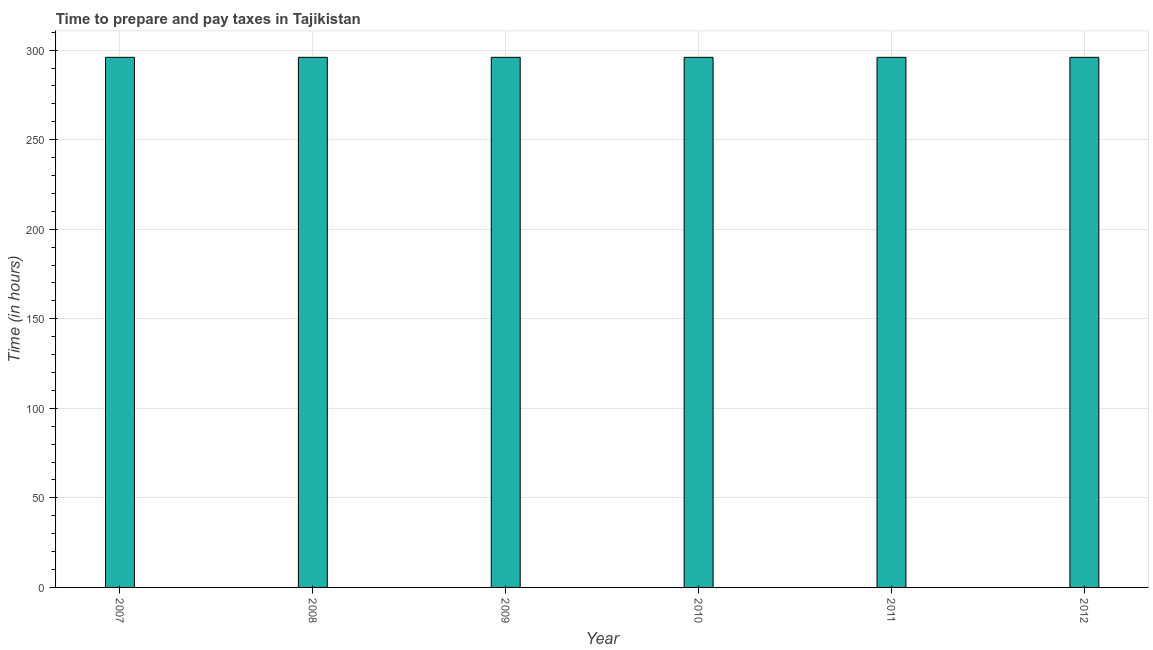Does the graph contain grids?
Your answer should be very brief. Yes. What is the title of the graph?
Ensure brevity in your answer.  Time to prepare and pay taxes in Tajikistan. What is the label or title of the Y-axis?
Provide a succinct answer. Time (in hours). What is the time to prepare and pay taxes in 2011?
Offer a very short reply. 296. Across all years, what is the maximum time to prepare and pay taxes?
Your response must be concise. 296. Across all years, what is the minimum time to prepare and pay taxes?
Your answer should be very brief. 296. In which year was the time to prepare and pay taxes maximum?
Your answer should be compact. 2007. What is the sum of the time to prepare and pay taxes?
Make the answer very short. 1776. What is the average time to prepare and pay taxes per year?
Provide a short and direct response. 296. What is the median time to prepare and pay taxes?
Ensure brevity in your answer.  296. What is the ratio of the time to prepare and pay taxes in 2007 to that in 2012?
Keep it short and to the point. 1. Is the time to prepare and pay taxes in 2010 less than that in 2012?
Provide a succinct answer. No. Is the difference between the time to prepare and pay taxes in 2010 and 2011 greater than the difference between any two years?
Offer a terse response. Yes. Is the sum of the time to prepare and pay taxes in 2011 and 2012 greater than the maximum time to prepare and pay taxes across all years?
Your response must be concise. Yes. What is the difference between the highest and the lowest time to prepare and pay taxes?
Keep it short and to the point. 0. In how many years, is the time to prepare and pay taxes greater than the average time to prepare and pay taxes taken over all years?
Ensure brevity in your answer.  0. Are the values on the major ticks of Y-axis written in scientific E-notation?
Provide a short and direct response. No. What is the Time (in hours) of 2007?
Ensure brevity in your answer.  296. What is the Time (in hours) of 2008?
Keep it short and to the point. 296. What is the Time (in hours) of 2009?
Provide a short and direct response. 296. What is the Time (in hours) in 2010?
Make the answer very short. 296. What is the Time (in hours) of 2011?
Make the answer very short. 296. What is the Time (in hours) of 2012?
Your response must be concise. 296. What is the difference between the Time (in hours) in 2007 and 2009?
Offer a terse response. 0. What is the difference between the Time (in hours) in 2007 and 2011?
Your answer should be very brief. 0. What is the difference between the Time (in hours) in 2007 and 2012?
Offer a very short reply. 0. What is the difference between the Time (in hours) in 2008 and 2009?
Provide a succinct answer. 0. What is the difference between the Time (in hours) in 2008 and 2010?
Your answer should be compact. 0. What is the difference between the Time (in hours) in 2009 and 2010?
Ensure brevity in your answer.  0. What is the difference between the Time (in hours) in 2009 and 2011?
Your response must be concise. 0. What is the difference between the Time (in hours) in 2010 and 2011?
Provide a short and direct response. 0. What is the difference between the Time (in hours) in 2011 and 2012?
Offer a terse response. 0. What is the ratio of the Time (in hours) in 2007 to that in 2010?
Provide a succinct answer. 1. What is the ratio of the Time (in hours) in 2007 to that in 2011?
Provide a succinct answer. 1. What is the ratio of the Time (in hours) in 2008 to that in 2009?
Keep it short and to the point. 1. What is the ratio of the Time (in hours) in 2008 to that in 2010?
Offer a very short reply. 1. What is the ratio of the Time (in hours) in 2009 to that in 2010?
Make the answer very short. 1. What is the ratio of the Time (in hours) in 2009 to that in 2012?
Provide a succinct answer. 1. What is the ratio of the Time (in hours) in 2010 to that in 2011?
Ensure brevity in your answer.  1. 